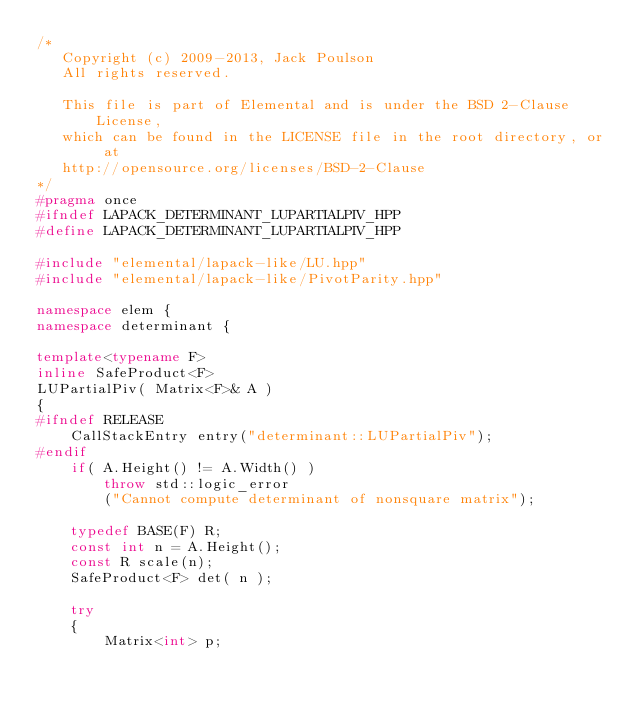<code> <loc_0><loc_0><loc_500><loc_500><_C++_>/*
   Copyright (c) 2009-2013, Jack Poulson
   All rights reserved.

   This file is part of Elemental and is under the BSD 2-Clause License, 
   which can be found in the LICENSE file in the root directory, or at 
   http://opensource.org/licenses/BSD-2-Clause
*/
#pragma once
#ifndef LAPACK_DETERMINANT_LUPARTIALPIV_HPP
#define LAPACK_DETERMINANT_LUPARTIALPIV_HPP

#include "elemental/lapack-like/LU.hpp"
#include "elemental/lapack-like/PivotParity.hpp"

namespace elem {
namespace determinant {

template<typename F>
inline SafeProduct<F> 
LUPartialPiv( Matrix<F>& A )
{
#ifndef RELEASE
    CallStackEntry entry("determinant::LUPartialPiv");
#endif
    if( A.Height() != A.Width() )
        throw std::logic_error
        ("Cannot compute determinant of nonsquare matrix");

    typedef BASE(F) R;
    const int n = A.Height();
    const R scale(n);
    SafeProduct<F> det( n );

    try
    {
        Matrix<int> p;</code> 